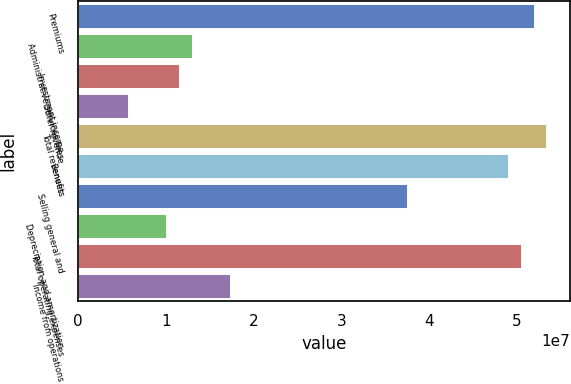Convert chart to OTSL. <chart><loc_0><loc_0><loc_500><loc_500><bar_chart><fcel>Premiums<fcel>Administrative services fees<fcel>Investment income<fcel>Other revenue<fcel>Total revenues<fcel>Benefits<fcel>Selling general and<fcel>Depreciation and amortization<fcel>Total operating expenses<fcel>Income from operations<nl><fcel>5.19053e+07<fcel>1.29763e+07<fcel>1.15345e+07<fcel>5.76725e+06<fcel>5.33471e+07<fcel>4.90216e+07<fcel>3.74871e+07<fcel>1.00927e+07<fcel>5.04634e+07<fcel>1.73018e+07<nl></chart> 